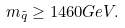<formula> <loc_0><loc_0><loc_500><loc_500>m _ { \tilde { q } } \geq 1 4 6 0 G e V .</formula> 